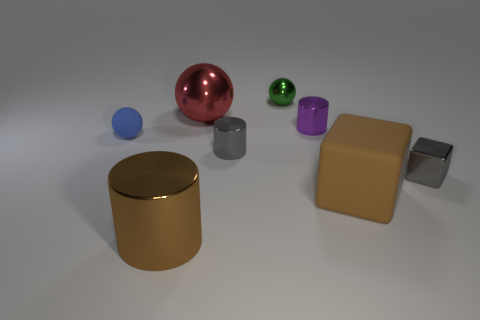How big is the metal object that is on the right side of the purple shiny cylinder?
Offer a very short reply. Small. Are there any yellow metallic cylinders that have the same size as the brown rubber block?
Your answer should be compact. No. There is a gray thing that is on the left side of the brown matte thing; does it have the same size as the large rubber thing?
Your response must be concise. No. What is the size of the red thing?
Your answer should be compact. Large. The large metallic thing that is behind the big brown object that is on the left side of the metal cylinder to the right of the small green sphere is what color?
Your response must be concise. Red. There is a small sphere that is behind the tiny purple metallic cylinder; is it the same color as the big ball?
Ensure brevity in your answer.  No. What number of objects are on the left side of the purple cylinder and in front of the gray metallic block?
Provide a short and direct response. 1. The other thing that is the same shape as the brown matte thing is what size?
Your response must be concise. Small. There is a small sphere left of the large shiny thing that is behind the tiny blue rubber sphere; what number of big objects are in front of it?
Your response must be concise. 2. There is a object that is left of the brown thing that is on the left side of the green shiny thing; what is its color?
Your answer should be compact. Blue. 